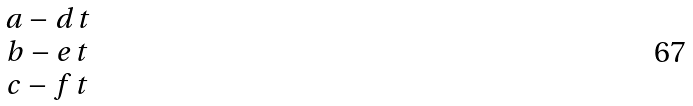Convert formula to latex. <formula><loc_0><loc_0><loc_500><loc_500>\begin{matrix} a - d \, t \\ b - e \, t \\ c - f \, t \end{matrix}</formula> 